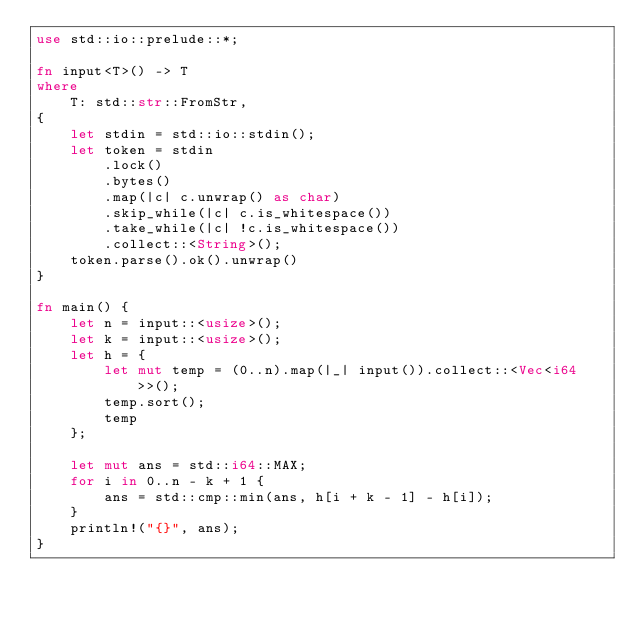Convert code to text. <code><loc_0><loc_0><loc_500><loc_500><_Rust_>use std::io::prelude::*;

fn input<T>() -> T
where
    T: std::str::FromStr,
{
    let stdin = std::io::stdin();
    let token = stdin
        .lock()
        .bytes()
        .map(|c| c.unwrap() as char)
        .skip_while(|c| c.is_whitespace())
        .take_while(|c| !c.is_whitespace())
        .collect::<String>();
    token.parse().ok().unwrap()
}

fn main() {
    let n = input::<usize>();
    let k = input::<usize>();
    let h = {
        let mut temp = (0..n).map(|_| input()).collect::<Vec<i64>>();
        temp.sort();
        temp
    };

    let mut ans = std::i64::MAX;
    for i in 0..n - k + 1 {
        ans = std::cmp::min(ans, h[i + k - 1] - h[i]);
    }
    println!("{}", ans);
}
</code> 